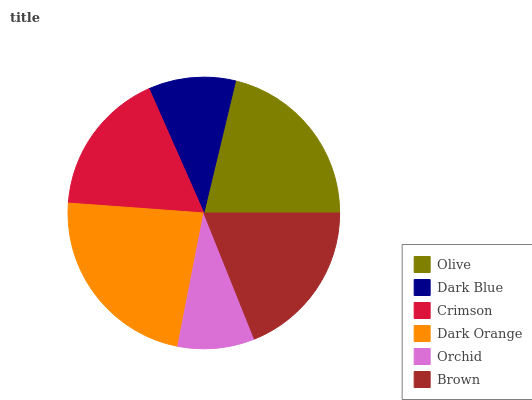Is Orchid the minimum?
Answer yes or no. Yes. Is Dark Orange the maximum?
Answer yes or no. Yes. Is Dark Blue the minimum?
Answer yes or no. No. Is Dark Blue the maximum?
Answer yes or no. No. Is Olive greater than Dark Blue?
Answer yes or no. Yes. Is Dark Blue less than Olive?
Answer yes or no. Yes. Is Dark Blue greater than Olive?
Answer yes or no. No. Is Olive less than Dark Blue?
Answer yes or no. No. Is Brown the high median?
Answer yes or no. Yes. Is Crimson the low median?
Answer yes or no. Yes. Is Dark Orange the high median?
Answer yes or no. No. Is Orchid the low median?
Answer yes or no. No. 